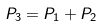<formula> <loc_0><loc_0><loc_500><loc_500>P _ { 3 } = P _ { 1 } + P _ { 2 }</formula> 